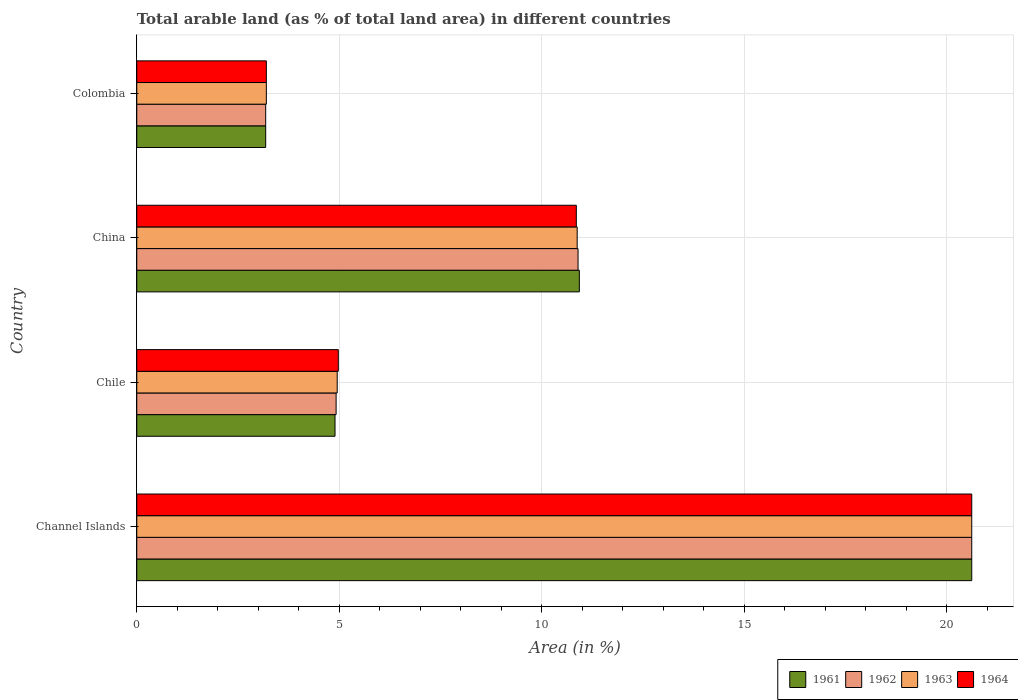How many groups of bars are there?
Make the answer very short. 4. How many bars are there on the 4th tick from the bottom?
Your answer should be very brief. 4. What is the label of the 1st group of bars from the top?
Provide a succinct answer. Colombia. In how many cases, is the number of bars for a given country not equal to the number of legend labels?
Make the answer very short. 0. What is the percentage of arable land in 1964 in Colombia?
Offer a terse response. 3.2. Across all countries, what is the maximum percentage of arable land in 1962?
Ensure brevity in your answer.  20.62. Across all countries, what is the minimum percentage of arable land in 1961?
Your answer should be very brief. 3.18. In which country was the percentage of arable land in 1963 maximum?
Make the answer very short. Channel Islands. What is the total percentage of arable land in 1962 in the graph?
Offer a very short reply. 39.62. What is the difference between the percentage of arable land in 1962 in Chile and that in China?
Offer a terse response. -5.97. What is the difference between the percentage of arable land in 1962 in Colombia and the percentage of arable land in 1963 in China?
Your answer should be compact. -7.69. What is the average percentage of arable land in 1964 per country?
Your answer should be compact. 9.91. What is the difference between the percentage of arable land in 1961 and percentage of arable land in 1962 in China?
Keep it short and to the point. 0.03. In how many countries, is the percentage of arable land in 1962 greater than 1 %?
Provide a succinct answer. 4. What is the ratio of the percentage of arable land in 1962 in Channel Islands to that in Colombia?
Give a very brief answer. 6.48. Is the percentage of arable land in 1961 in Chile less than that in China?
Offer a very short reply. Yes. Is the difference between the percentage of arable land in 1961 in Chile and Colombia greater than the difference between the percentage of arable land in 1962 in Chile and Colombia?
Make the answer very short. No. What is the difference between the highest and the second highest percentage of arable land in 1961?
Keep it short and to the point. 9.69. What is the difference between the highest and the lowest percentage of arable land in 1961?
Your response must be concise. 17.44. What does the 1st bar from the top in Channel Islands represents?
Your response must be concise. 1964. What does the 4th bar from the bottom in Colombia represents?
Provide a short and direct response. 1964. Is it the case that in every country, the sum of the percentage of arable land in 1962 and percentage of arable land in 1964 is greater than the percentage of arable land in 1963?
Provide a short and direct response. Yes. How many countries are there in the graph?
Offer a very short reply. 4. Where does the legend appear in the graph?
Keep it short and to the point. Bottom right. What is the title of the graph?
Ensure brevity in your answer.  Total arable land (as % of total land area) in different countries. What is the label or title of the X-axis?
Provide a short and direct response. Area (in %). What is the label or title of the Y-axis?
Offer a very short reply. Country. What is the Area (in %) in 1961 in Channel Islands?
Your response must be concise. 20.62. What is the Area (in %) of 1962 in Channel Islands?
Give a very brief answer. 20.62. What is the Area (in %) in 1963 in Channel Islands?
Provide a short and direct response. 20.62. What is the Area (in %) of 1964 in Channel Islands?
Your answer should be very brief. 20.62. What is the Area (in %) of 1961 in Chile?
Provide a short and direct response. 4.9. What is the Area (in %) of 1962 in Chile?
Ensure brevity in your answer.  4.92. What is the Area (in %) of 1963 in Chile?
Provide a short and direct response. 4.95. What is the Area (in %) of 1964 in Chile?
Your answer should be compact. 4.98. What is the Area (in %) of 1961 in China?
Keep it short and to the point. 10.93. What is the Area (in %) of 1962 in China?
Your answer should be very brief. 10.9. What is the Area (in %) in 1963 in China?
Keep it short and to the point. 10.88. What is the Area (in %) of 1964 in China?
Your answer should be compact. 10.85. What is the Area (in %) in 1961 in Colombia?
Offer a very short reply. 3.18. What is the Area (in %) of 1962 in Colombia?
Ensure brevity in your answer.  3.18. What is the Area (in %) in 1963 in Colombia?
Give a very brief answer. 3.2. What is the Area (in %) of 1964 in Colombia?
Your answer should be compact. 3.2. Across all countries, what is the maximum Area (in %) in 1961?
Ensure brevity in your answer.  20.62. Across all countries, what is the maximum Area (in %) in 1962?
Offer a very short reply. 20.62. Across all countries, what is the maximum Area (in %) in 1963?
Provide a succinct answer. 20.62. Across all countries, what is the maximum Area (in %) of 1964?
Give a very brief answer. 20.62. Across all countries, what is the minimum Area (in %) of 1961?
Your response must be concise. 3.18. Across all countries, what is the minimum Area (in %) of 1962?
Provide a short and direct response. 3.18. Across all countries, what is the minimum Area (in %) of 1963?
Ensure brevity in your answer.  3.2. Across all countries, what is the minimum Area (in %) in 1964?
Ensure brevity in your answer.  3.2. What is the total Area (in %) in 1961 in the graph?
Provide a succinct answer. 39.63. What is the total Area (in %) in 1962 in the graph?
Ensure brevity in your answer.  39.62. What is the total Area (in %) of 1963 in the graph?
Give a very brief answer. 39.64. What is the total Area (in %) of 1964 in the graph?
Give a very brief answer. 39.65. What is the difference between the Area (in %) in 1961 in Channel Islands and that in Chile?
Provide a succinct answer. 15.72. What is the difference between the Area (in %) in 1962 in Channel Islands and that in Chile?
Make the answer very short. 15.7. What is the difference between the Area (in %) in 1963 in Channel Islands and that in Chile?
Keep it short and to the point. 15.67. What is the difference between the Area (in %) in 1964 in Channel Islands and that in Chile?
Your answer should be compact. 15.64. What is the difference between the Area (in %) of 1961 in Channel Islands and that in China?
Your answer should be compact. 9.69. What is the difference between the Area (in %) in 1962 in Channel Islands and that in China?
Make the answer very short. 9.72. What is the difference between the Area (in %) in 1963 in Channel Islands and that in China?
Offer a terse response. 9.74. What is the difference between the Area (in %) in 1964 in Channel Islands and that in China?
Your answer should be compact. 9.76. What is the difference between the Area (in %) in 1961 in Channel Islands and that in Colombia?
Provide a short and direct response. 17.44. What is the difference between the Area (in %) of 1962 in Channel Islands and that in Colombia?
Your response must be concise. 17.44. What is the difference between the Area (in %) of 1963 in Channel Islands and that in Colombia?
Provide a succinct answer. 17.42. What is the difference between the Area (in %) in 1964 in Channel Islands and that in Colombia?
Ensure brevity in your answer.  17.42. What is the difference between the Area (in %) of 1961 in Chile and that in China?
Provide a short and direct response. -6.03. What is the difference between the Area (in %) of 1962 in Chile and that in China?
Offer a very short reply. -5.97. What is the difference between the Area (in %) of 1963 in Chile and that in China?
Offer a very short reply. -5.93. What is the difference between the Area (in %) of 1964 in Chile and that in China?
Ensure brevity in your answer.  -5.88. What is the difference between the Area (in %) in 1961 in Chile and that in Colombia?
Ensure brevity in your answer.  1.71. What is the difference between the Area (in %) in 1962 in Chile and that in Colombia?
Provide a short and direct response. 1.74. What is the difference between the Area (in %) of 1963 in Chile and that in Colombia?
Your answer should be very brief. 1.75. What is the difference between the Area (in %) of 1964 in Chile and that in Colombia?
Make the answer very short. 1.78. What is the difference between the Area (in %) in 1961 in China and that in Colombia?
Provide a short and direct response. 7.75. What is the difference between the Area (in %) of 1962 in China and that in Colombia?
Offer a terse response. 7.71. What is the difference between the Area (in %) in 1963 in China and that in Colombia?
Give a very brief answer. 7.68. What is the difference between the Area (in %) in 1964 in China and that in Colombia?
Offer a very short reply. 7.65. What is the difference between the Area (in %) of 1961 in Channel Islands and the Area (in %) of 1962 in Chile?
Make the answer very short. 15.7. What is the difference between the Area (in %) of 1961 in Channel Islands and the Area (in %) of 1963 in Chile?
Provide a short and direct response. 15.67. What is the difference between the Area (in %) in 1961 in Channel Islands and the Area (in %) in 1964 in Chile?
Give a very brief answer. 15.64. What is the difference between the Area (in %) in 1962 in Channel Islands and the Area (in %) in 1963 in Chile?
Your answer should be very brief. 15.67. What is the difference between the Area (in %) in 1962 in Channel Islands and the Area (in %) in 1964 in Chile?
Keep it short and to the point. 15.64. What is the difference between the Area (in %) of 1963 in Channel Islands and the Area (in %) of 1964 in Chile?
Provide a short and direct response. 15.64. What is the difference between the Area (in %) in 1961 in Channel Islands and the Area (in %) in 1962 in China?
Provide a succinct answer. 9.72. What is the difference between the Area (in %) in 1961 in Channel Islands and the Area (in %) in 1963 in China?
Provide a short and direct response. 9.74. What is the difference between the Area (in %) in 1961 in Channel Islands and the Area (in %) in 1964 in China?
Make the answer very short. 9.76. What is the difference between the Area (in %) in 1962 in Channel Islands and the Area (in %) in 1963 in China?
Your answer should be compact. 9.74. What is the difference between the Area (in %) in 1962 in Channel Islands and the Area (in %) in 1964 in China?
Keep it short and to the point. 9.76. What is the difference between the Area (in %) in 1963 in Channel Islands and the Area (in %) in 1964 in China?
Give a very brief answer. 9.76. What is the difference between the Area (in %) in 1961 in Channel Islands and the Area (in %) in 1962 in Colombia?
Ensure brevity in your answer.  17.44. What is the difference between the Area (in %) of 1961 in Channel Islands and the Area (in %) of 1963 in Colombia?
Offer a very short reply. 17.42. What is the difference between the Area (in %) in 1961 in Channel Islands and the Area (in %) in 1964 in Colombia?
Provide a succinct answer. 17.42. What is the difference between the Area (in %) of 1962 in Channel Islands and the Area (in %) of 1963 in Colombia?
Offer a terse response. 17.42. What is the difference between the Area (in %) of 1962 in Channel Islands and the Area (in %) of 1964 in Colombia?
Your answer should be very brief. 17.42. What is the difference between the Area (in %) in 1963 in Channel Islands and the Area (in %) in 1964 in Colombia?
Provide a succinct answer. 17.42. What is the difference between the Area (in %) of 1961 in Chile and the Area (in %) of 1962 in China?
Provide a short and direct response. -6. What is the difference between the Area (in %) of 1961 in Chile and the Area (in %) of 1963 in China?
Your answer should be very brief. -5.98. What is the difference between the Area (in %) in 1961 in Chile and the Area (in %) in 1964 in China?
Provide a succinct answer. -5.96. What is the difference between the Area (in %) in 1962 in Chile and the Area (in %) in 1963 in China?
Provide a short and direct response. -5.95. What is the difference between the Area (in %) in 1962 in Chile and the Area (in %) in 1964 in China?
Your answer should be compact. -5.93. What is the difference between the Area (in %) in 1963 in Chile and the Area (in %) in 1964 in China?
Your response must be concise. -5.9. What is the difference between the Area (in %) of 1961 in Chile and the Area (in %) of 1962 in Colombia?
Offer a very short reply. 1.71. What is the difference between the Area (in %) in 1961 in Chile and the Area (in %) in 1963 in Colombia?
Your response must be concise. 1.7. What is the difference between the Area (in %) of 1961 in Chile and the Area (in %) of 1964 in Colombia?
Your answer should be very brief. 1.7. What is the difference between the Area (in %) in 1962 in Chile and the Area (in %) in 1963 in Colombia?
Ensure brevity in your answer.  1.72. What is the difference between the Area (in %) in 1962 in Chile and the Area (in %) in 1964 in Colombia?
Make the answer very short. 1.72. What is the difference between the Area (in %) in 1963 in Chile and the Area (in %) in 1964 in Colombia?
Offer a very short reply. 1.75. What is the difference between the Area (in %) of 1961 in China and the Area (in %) of 1962 in Colombia?
Your response must be concise. 7.75. What is the difference between the Area (in %) of 1961 in China and the Area (in %) of 1963 in Colombia?
Your answer should be compact. 7.73. What is the difference between the Area (in %) in 1961 in China and the Area (in %) in 1964 in Colombia?
Make the answer very short. 7.73. What is the difference between the Area (in %) of 1962 in China and the Area (in %) of 1963 in Colombia?
Your answer should be very brief. 7.7. What is the difference between the Area (in %) of 1962 in China and the Area (in %) of 1964 in Colombia?
Offer a terse response. 7.7. What is the difference between the Area (in %) of 1963 in China and the Area (in %) of 1964 in Colombia?
Provide a succinct answer. 7.68. What is the average Area (in %) of 1961 per country?
Your answer should be compact. 9.91. What is the average Area (in %) in 1962 per country?
Give a very brief answer. 9.91. What is the average Area (in %) of 1963 per country?
Provide a short and direct response. 9.91. What is the average Area (in %) in 1964 per country?
Your response must be concise. 9.91. What is the difference between the Area (in %) of 1963 and Area (in %) of 1964 in Channel Islands?
Provide a short and direct response. 0. What is the difference between the Area (in %) of 1961 and Area (in %) of 1962 in Chile?
Your response must be concise. -0.03. What is the difference between the Area (in %) of 1961 and Area (in %) of 1963 in Chile?
Give a very brief answer. -0.05. What is the difference between the Area (in %) in 1961 and Area (in %) in 1964 in Chile?
Make the answer very short. -0.08. What is the difference between the Area (in %) of 1962 and Area (in %) of 1963 in Chile?
Give a very brief answer. -0.03. What is the difference between the Area (in %) of 1962 and Area (in %) of 1964 in Chile?
Ensure brevity in your answer.  -0.05. What is the difference between the Area (in %) in 1963 and Area (in %) in 1964 in Chile?
Make the answer very short. -0.03. What is the difference between the Area (in %) in 1961 and Area (in %) in 1962 in China?
Your response must be concise. 0.03. What is the difference between the Area (in %) in 1961 and Area (in %) in 1963 in China?
Offer a very short reply. 0.05. What is the difference between the Area (in %) of 1961 and Area (in %) of 1964 in China?
Give a very brief answer. 0.07. What is the difference between the Area (in %) of 1962 and Area (in %) of 1963 in China?
Provide a short and direct response. 0.02. What is the difference between the Area (in %) in 1962 and Area (in %) in 1964 in China?
Make the answer very short. 0.04. What is the difference between the Area (in %) of 1963 and Area (in %) of 1964 in China?
Provide a succinct answer. 0.02. What is the difference between the Area (in %) of 1961 and Area (in %) of 1962 in Colombia?
Keep it short and to the point. 0. What is the difference between the Area (in %) in 1961 and Area (in %) in 1963 in Colombia?
Offer a very short reply. -0.02. What is the difference between the Area (in %) of 1961 and Area (in %) of 1964 in Colombia?
Provide a succinct answer. -0.02. What is the difference between the Area (in %) of 1962 and Area (in %) of 1963 in Colombia?
Ensure brevity in your answer.  -0.02. What is the difference between the Area (in %) in 1962 and Area (in %) in 1964 in Colombia?
Your response must be concise. -0.02. What is the difference between the Area (in %) in 1963 and Area (in %) in 1964 in Colombia?
Offer a terse response. 0. What is the ratio of the Area (in %) of 1961 in Channel Islands to that in Chile?
Your answer should be very brief. 4.21. What is the ratio of the Area (in %) of 1962 in Channel Islands to that in Chile?
Make the answer very short. 4.19. What is the ratio of the Area (in %) in 1963 in Channel Islands to that in Chile?
Make the answer very short. 4.17. What is the ratio of the Area (in %) in 1964 in Channel Islands to that in Chile?
Your answer should be very brief. 4.14. What is the ratio of the Area (in %) in 1961 in Channel Islands to that in China?
Keep it short and to the point. 1.89. What is the ratio of the Area (in %) of 1962 in Channel Islands to that in China?
Your answer should be compact. 1.89. What is the ratio of the Area (in %) of 1963 in Channel Islands to that in China?
Your response must be concise. 1.9. What is the ratio of the Area (in %) of 1964 in Channel Islands to that in China?
Offer a very short reply. 1.9. What is the ratio of the Area (in %) of 1961 in Channel Islands to that in Colombia?
Your answer should be compact. 6.48. What is the ratio of the Area (in %) in 1962 in Channel Islands to that in Colombia?
Ensure brevity in your answer.  6.48. What is the ratio of the Area (in %) in 1963 in Channel Islands to that in Colombia?
Offer a very short reply. 6.44. What is the ratio of the Area (in %) in 1964 in Channel Islands to that in Colombia?
Your response must be concise. 6.44. What is the ratio of the Area (in %) of 1961 in Chile to that in China?
Offer a terse response. 0.45. What is the ratio of the Area (in %) of 1962 in Chile to that in China?
Provide a succinct answer. 0.45. What is the ratio of the Area (in %) in 1963 in Chile to that in China?
Offer a terse response. 0.46. What is the ratio of the Area (in %) in 1964 in Chile to that in China?
Provide a short and direct response. 0.46. What is the ratio of the Area (in %) in 1961 in Chile to that in Colombia?
Your answer should be compact. 1.54. What is the ratio of the Area (in %) in 1962 in Chile to that in Colombia?
Your answer should be compact. 1.55. What is the ratio of the Area (in %) in 1963 in Chile to that in Colombia?
Make the answer very short. 1.55. What is the ratio of the Area (in %) of 1964 in Chile to that in Colombia?
Your answer should be compact. 1.56. What is the ratio of the Area (in %) in 1961 in China to that in Colombia?
Keep it short and to the point. 3.43. What is the ratio of the Area (in %) in 1962 in China to that in Colombia?
Make the answer very short. 3.42. What is the ratio of the Area (in %) of 1963 in China to that in Colombia?
Keep it short and to the point. 3.4. What is the ratio of the Area (in %) of 1964 in China to that in Colombia?
Keep it short and to the point. 3.39. What is the difference between the highest and the second highest Area (in %) in 1961?
Offer a very short reply. 9.69. What is the difference between the highest and the second highest Area (in %) in 1962?
Ensure brevity in your answer.  9.72. What is the difference between the highest and the second highest Area (in %) in 1963?
Make the answer very short. 9.74. What is the difference between the highest and the second highest Area (in %) in 1964?
Provide a short and direct response. 9.76. What is the difference between the highest and the lowest Area (in %) of 1961?
Offer a terse response. 17.44. What is the difference between the highest and the lowest Area (in %) in 1962?
Provide a short and direct response. 17.44. What is the difference between the highest and the lowest Area (in %) in 1963?
Your answer should be very brief. 17.42. What is the difference between the highest and the lowest Area (in %) in 1964?
Provide a short and direct response. 17.42. 